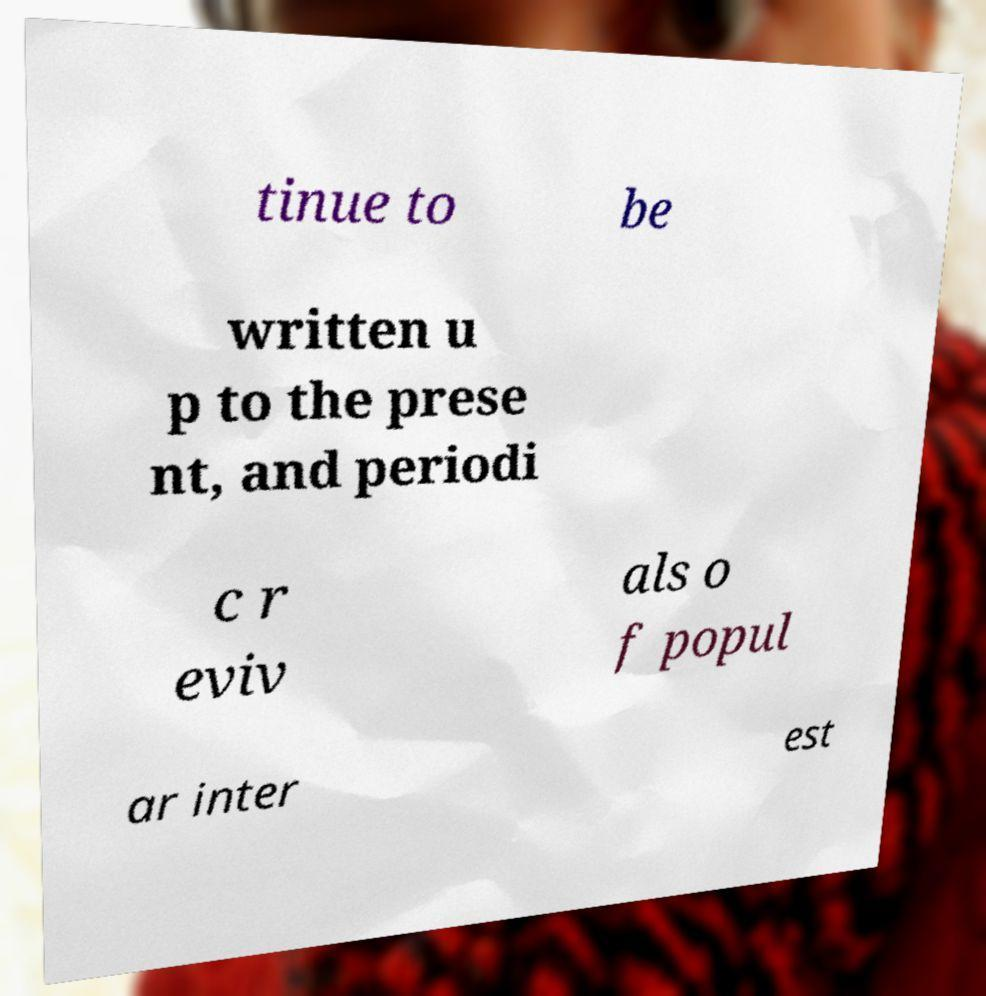Can you read and provide the text displayed in the image?This photo seems to have some interesting text. Can you extract and type it out for me? tinue to be written u p to the prese nt, and periodi c r eviv als o f popul ar inter est 